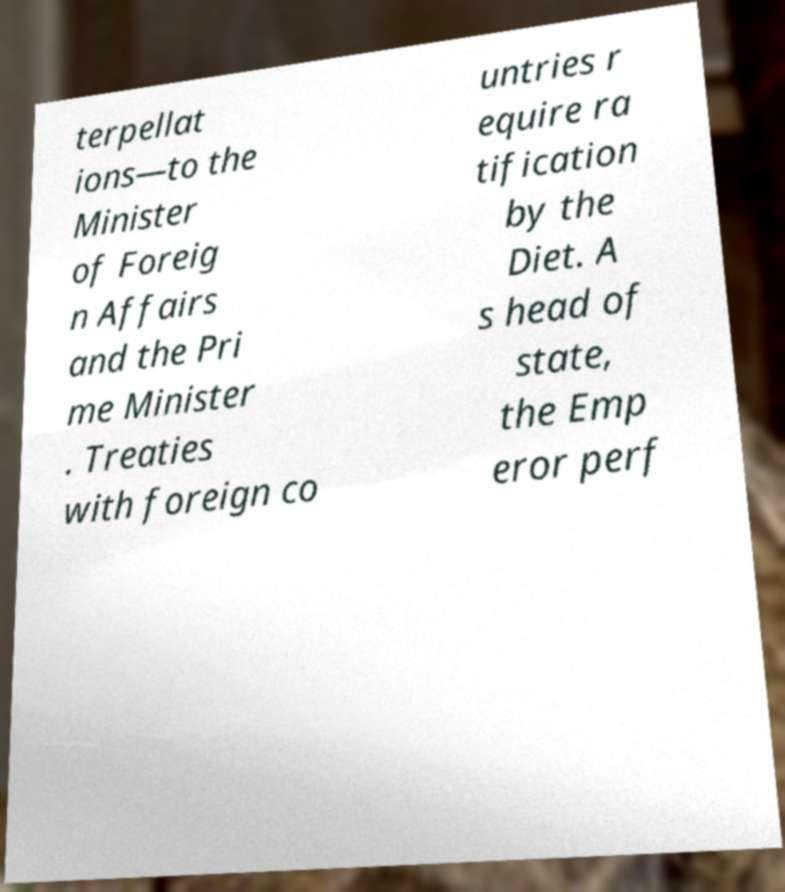Please read and relay the text visible in this image. What does it say? terpellat ions—to the Minister of Foreig n Affairs and the Pri me Minister . Treaties with foreign co untries r equire ra tification by the Diet. A s head of state, the Emp eror perf 